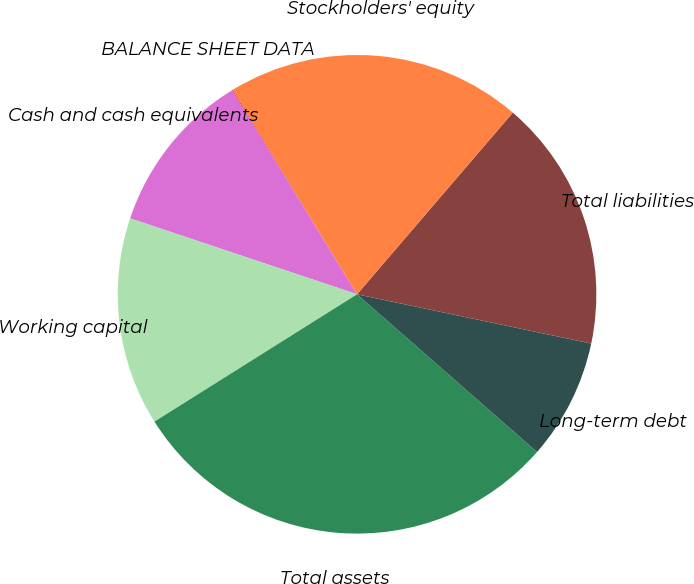Convert chart. <chart><loc_0><loc_0><loc_500><loc_500><pie_chart><fcel>BALANCE SHEET DATA<fcel>Cash and cash equivalents<fcel>Working capital<fcel>Total assets<fcel>Long-term debt<fcel>Total liabilities<fcel>Stockholders' equity<nl><fcel>0.05%<fcel>11.11%<fcel>14.07%<fcel>29.62%<fcel>8.15%<fcel>17.02%<fcel>19.98%<nl></chart> 